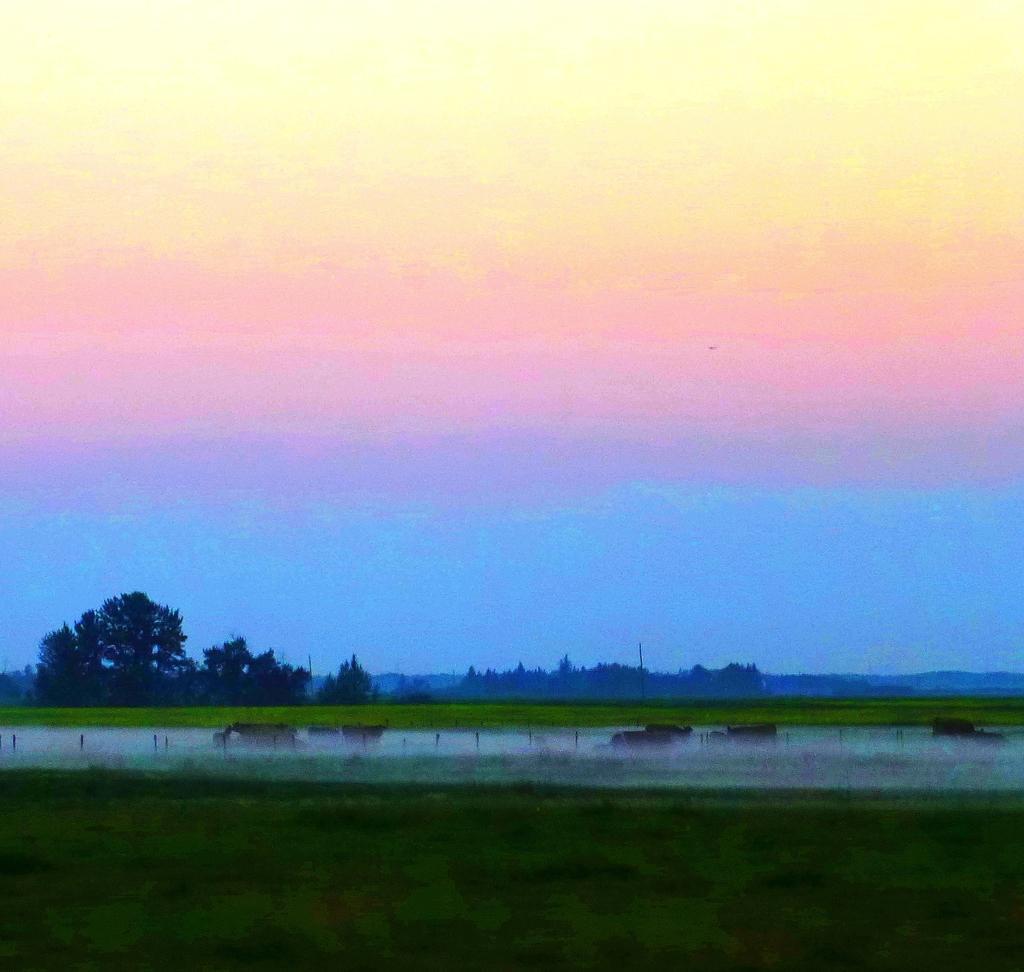Can you describe this image briefly? There is water and the ground is greenery beside it and there are trees in the background. 